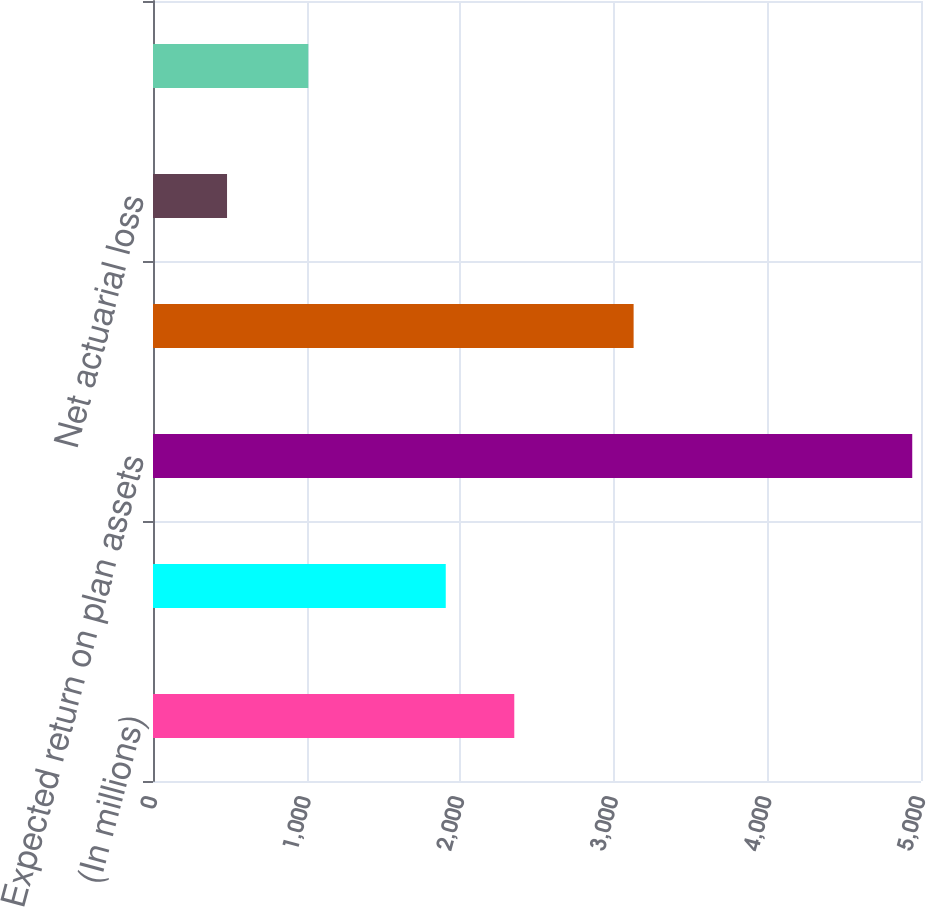Convert chart to OTSL. <chart><loc_0><loc_0><loc_500><loc_500><bar_chart><fcel>(In millions)<fcel>Service cost for benefits<fcel>Expected return on plan assets<fcel>Interest cost on benefit<fcel>Net actuarial loss<fcel>Pension plans cost<nl><fcel>2352.1<fcel>1906<fcel>4943<fcel>3129<fcel>482<fcel>1011<nl></chart> 